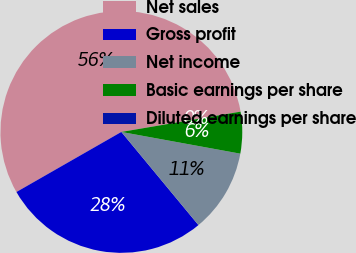Convert chart to OTSL. <chart><loc_0><loc_0><loc_500><loc_500><pie_chart><fcel>Net sales<fcel>Gross profit<fcel>Net income<fcel>Basic earnings per share<fcel>Diluted earnings per share<nl><fcel>55.59%<fcel>27.73%<fcel>11.12%<fcel>5.56%<fcel>0.0%<nl></chart> 